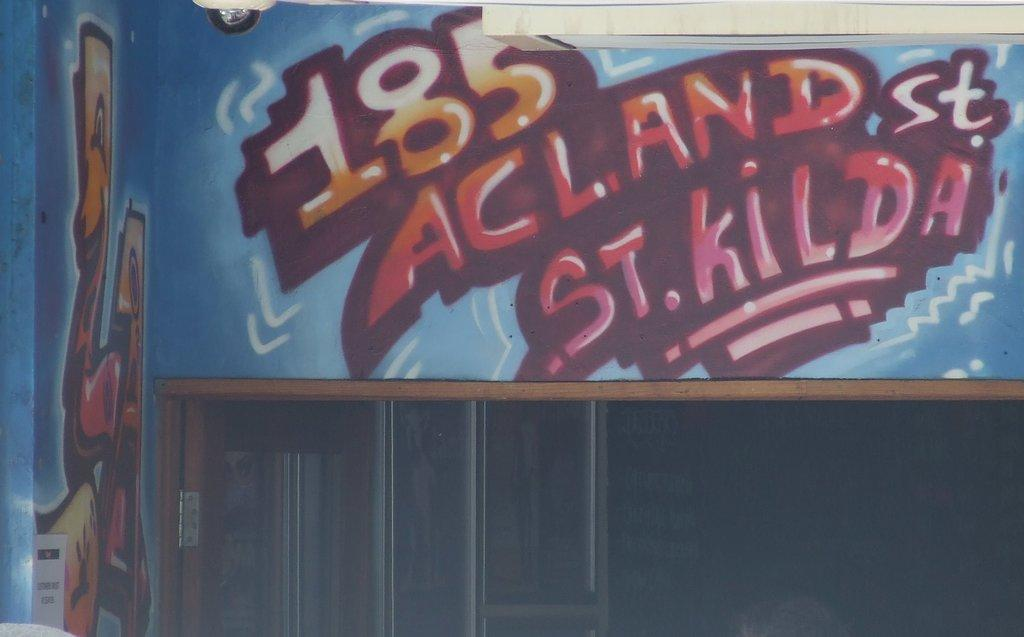<image>
Create a compact narrative representing the image presented. A sign on a wood panel wall that says 185 Acland St St. Kilda. 